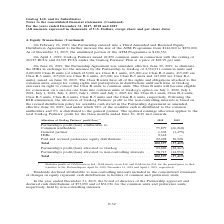According to Gaslog's financial document, What was the amount of cash distributions in 2019 for common units? According to the financial document, $73,090 (in thousands). The relevant text states: "ership approved and declared cash distributions of $73,090 and of $31,036 for the common units and preference units, respectively, held by non-controlling inte..." Also, How much of the ATM Programme is unutilized in 2019? According to the financial document, $126,556 (in thousands). The relevant text states: "19, the unutilized portion of the ATM Programme is $126,556...." Also, What are the components of Class B units? The document contains multiple relevant values: Class B-1 units, Class B-2 units, Class B-3 units, Class B-4 units, Class B-5 units, Class B-6 units. From the document: "nits, 415,000 are Class B-5 units and 415,000 are Class B-6 units), issued on June 30, 2019. The Class B units have all of the rights and obligations ..." Additionally, In which year was the paid and accrued preference equity distributions higher? According to the financial document, 2019. The relevant text states: ") For the years ended December 31, 2017, 2018 and 2019 (All amounts expressed in thousands of U.S. Dollars, except share and per share data)..." Also, can you calculate: What was the change in size of the ATM Programme? Based on the calculation: $250,000 - $144,040 , the result is 105960. This is based on the information: "e the size of the ATM Programme from $144,040 to $250,000. As of December 31, 2019, the unutilized portion of the ATM Programme is $126,556. ther increase the size of the ATM Programme from $144,040 t..." The key data points involved are: 144,040, 250,000. Also, can you calculate: What was the percentage change in Partnership’s profit/(loss) allocated to GasLog from 2018 to 2019? To answer this question, I need to perform calculations using the financial data. The calculation is: (-22,467  - 23,882)/23,882 , which equals -194.08 (percentage). This is based on the information: "hip’s profit/(loss) allocated to GasLog . 23,882 (22,467) Partnership’s profit/(loss) allocated to non-controlling interests . 78,715 (14,952) Partnership’s profit/(loss) allocated to GasLog . 23,882 ..." The key data points involved are: 22,467, 23,882. 